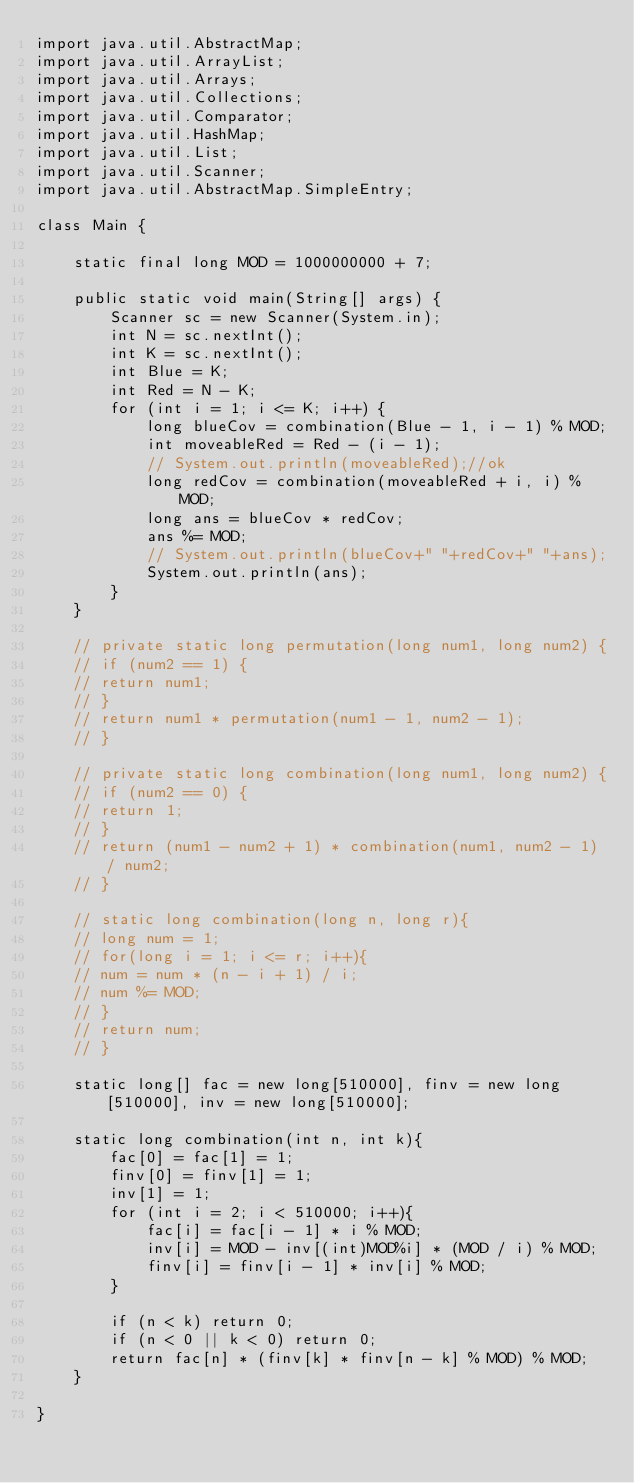<code> <loc_0><loc_0><loc_500><loc_500><_Java_>import java.util.AbstractMap;
import java.util.ArrayList;
import java.util.Arrays;
import java.util.Collections;
import java.util.Comparator;
import java.util.HashMap;
import java.util.List;
import java.util.Scanner;
import java.util.AbstractMap.SimpleEntry;

class Main {

    static final long MOD = 1000000000 + 7;

    public static void main(String[] args) {
        Scanner sc = new Scanner(System.in);
        int N = sc.nextInt();
        int K = sc.nextInt();
        int Blue = K;
        int Red = N - K;
        for (int i = 1; i <= K; i++) {
            long blueCov = combination(Blue - 1, i - 1) % MOD;
            int moveableRed = Red - (i - 1);
            // System.out.println(moveableRed);//ok
            long redCov = combination(moveableRed + i, i) % MOD;
            long ans = blueCov * redCov;
            ans %= MOD;
            // System.out.println(blueCov+" "+redCov+" "+ans);
            System.out.println(ans);
        }
    }

    // private static long permutation(long num1, long num2) {
    // if (num2 == 1) {
    // return num1;
    // }
    // return num1 * permutation(num1 - 1, num2 - 1);
    // }

    // private static long combination(long num1, long num2) {
    // if (num2 == 0) {
    // return 1;
    // }
    // return (num1 - num2 + 1) * combination(num1, num2 - 1) / num2;
    // }

    // static long combination(long n, long r){
    // long num = 1;
    // for(long i = 1; i <= r; i++){
    // num = num * (n - i + 1) / i;
    // num %= MOD;
    // }
    // return num;
    // }

    static long[] fac = new long[510000], finv = new long[510000], inv = new long[510000];

    static long combination(int n, int k){        
        fac[0] = fac[1] = 1;
        finv[0] = finv[1] = 1;
        inv[1] = 1;
        for (int i = 2; i < 510000; i++){
            fac[i] = fac[i - 1] * i % MOD;
            inv[i] = MOD - inv[(int)MOD%i] * (MOD / i) % MOD;
            finv[i] = finv[i - 1] * inv[i] % MOD;
        }

        if (n < k) return 0;
        if (n < 0 || k < 0) return 0;
        return fac[n] * (finv[k] * finv[n - k] % MOD) % MOD;
    }

}</code> 